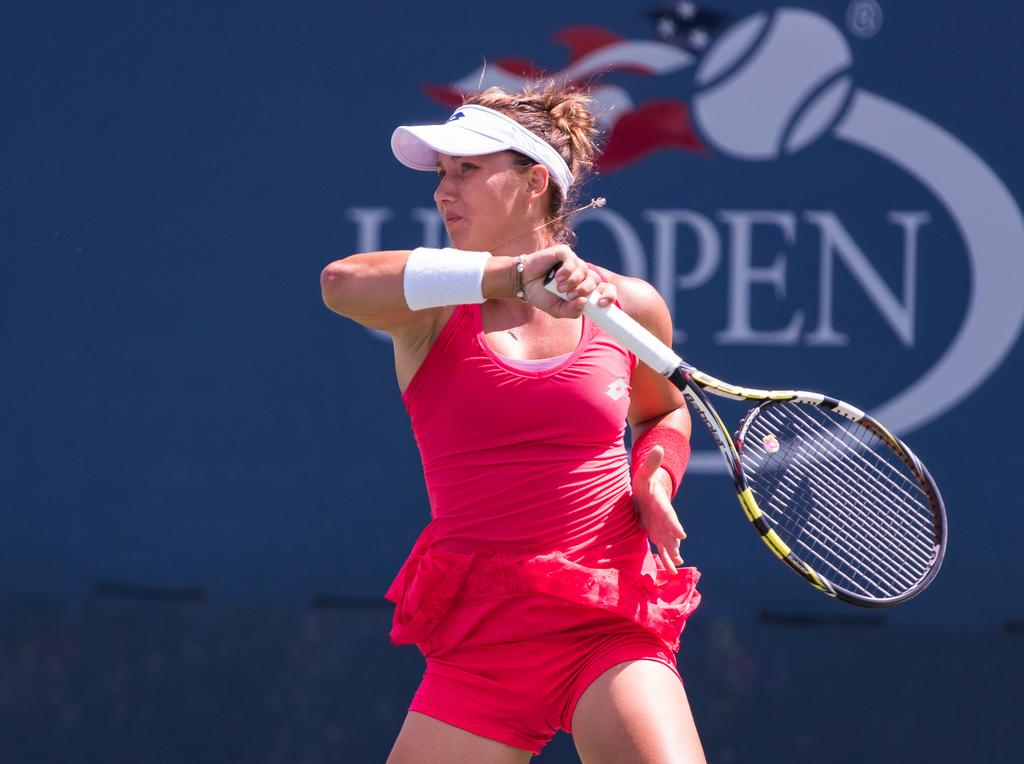Who is the main subject in the image? There is a woman in the image. What is the woman doing in the image? The woman is playing tennis. What object is the woman holding in the image? The woman is holding a racket. What can be seen in the background of the image? There is a poster in the background of the image. Where is the linen stored in the image? There is no mention of linen in the image, so it cannot be determined where it might be stored. 